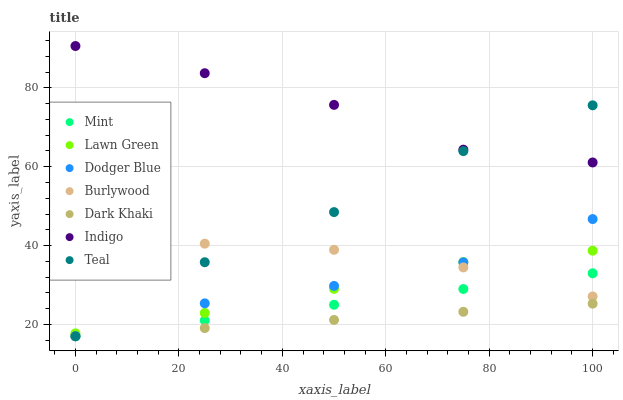Does Dark Khaki have the minimum area under the curve?
Answer yes or no. Yes. Does Indigo have the maximum area under the curve?
Answer yes or no. Yes. Does Burlywood have the minimum area under the curve?
Answer yes or no. No. Does Burlywood have the maximum area under the curve?
Answer yes or no. No. Is Mint the smoothest?
Answer yes or no. Yes. Is Teal the roughest?
Answer yes or no. Yes. Is Indigo the smoothest?
Answer yes or no. No. Is Indigo the roughest?
Answer yes or no. No. Does Dark Khaki have the lowest value?
Answer yes or no. Yes. Does Burlywood have the lowest value?
Answer yes or no. No. Does Indigo have the highest value?
Answer yes or no. Yes. Does Burlywood have the highest value?
Answer yes or no. No. Is Dodger Blue less than Indigo?
Answer yes or no. Yes. Is Indigo greater than Dodger Blue?
Answer yes or no. Yes. Does Burlywood intersect Lawn Green?
Answer yes or no. Yes. Is Burlywood less than Lawn Green?
Answer yes or no. No. Is Burlywood greater than Lawn Green?
Answer yes or no. No. Does Dodger Blue intersect Indigo?
Answer yes or no. No. 